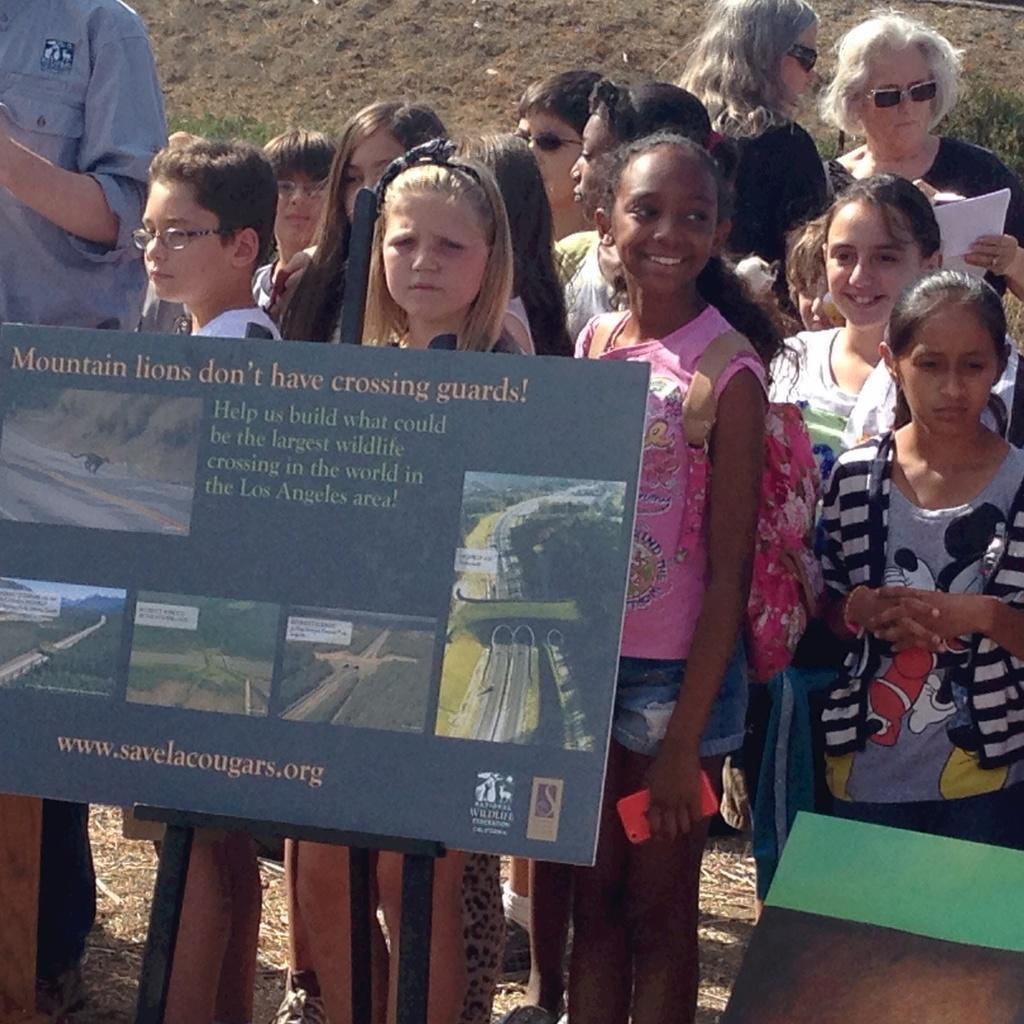Could you give a brief overview of what you see in this image? In the picture I can see a group of people are standing on the ground. Here I can see a board on which I can see photos of an animal, trees, roads and something written on the board. In the background I can see the grass and some other objects. 